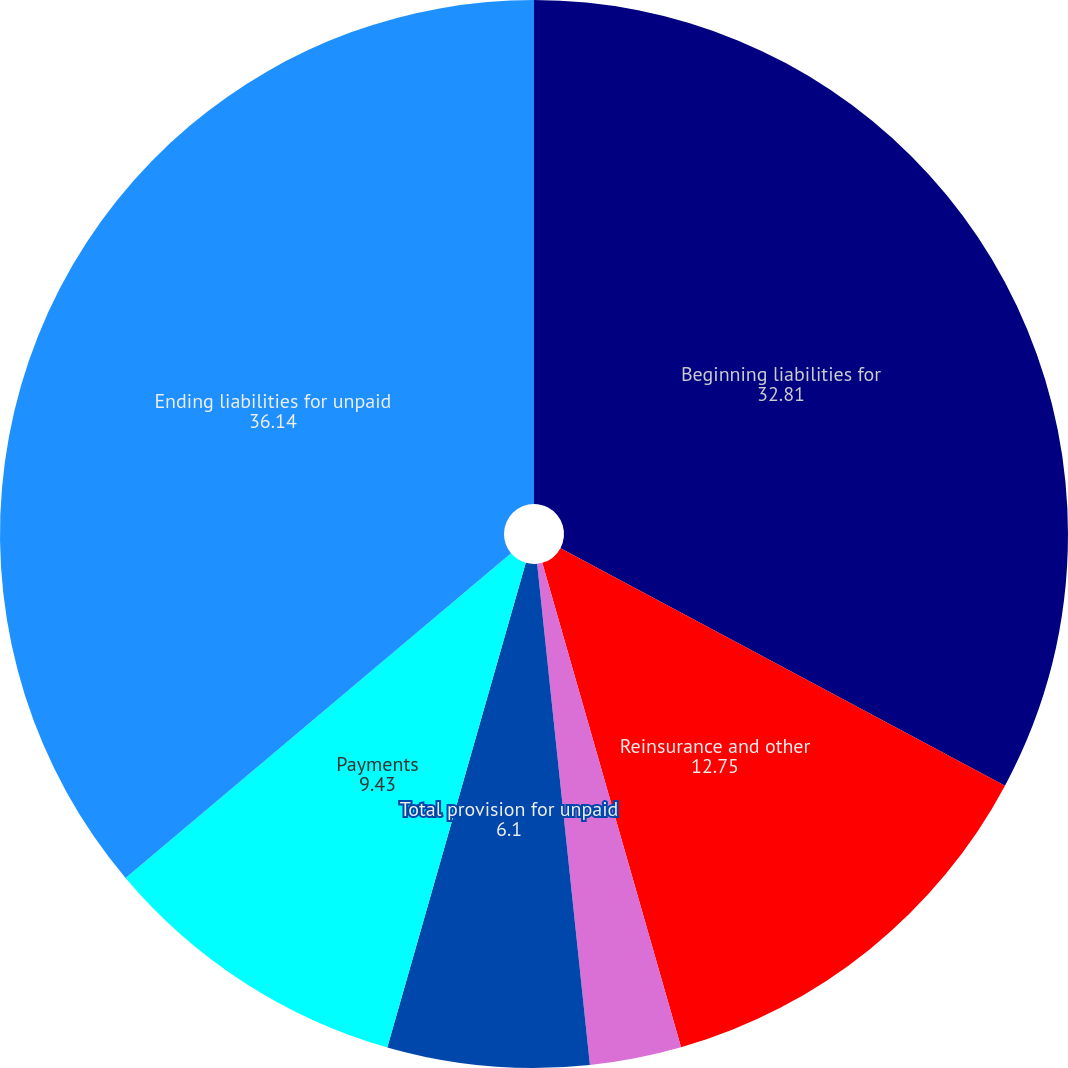Convert chart to OTSL. <chart><loc_0><loc_0><loc_500><loc_500><pie_chart><fcel>Beginning liabilities for<fcel>Reinsurance and other<fcel>Prior accident years<fcel>Total provision for unpaid<fcel>Payments<fcel>Ending liabilities for unpaid<nl><fcel>32.81%<fcel>12.75%<fcel>2.77%<fcel>6.1%<fcel>9.43%<fcel>36.14%<nl></chart> 